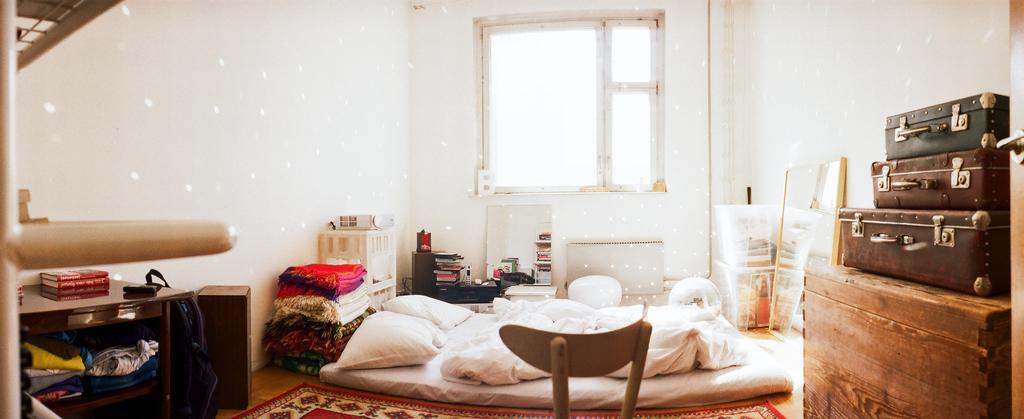In one or two sentences, can you explain what this image depicts? This picture was taken from inside. In this picture there is a bed. On top of it there are pillows. Beside the bed there are blankets. Behind the blankets there is a table. On top of it there is a object. At the back side there is a window. At the right side of the image there is a table. On top of it there are three suitcases. At the left side of the image there is a table. Inside that there are clothes. On top of the table there are books. 